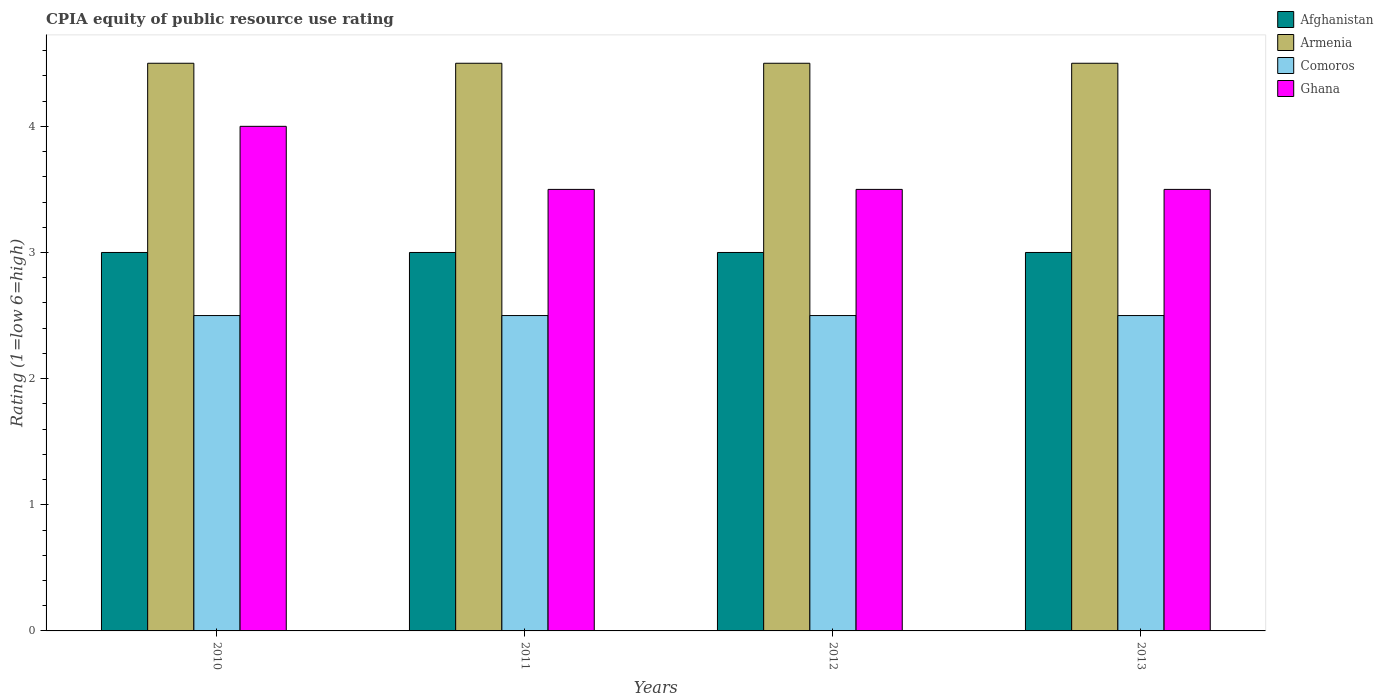What is the label of the 4th group of bars from the left?
Your answer should be very brief. 2013. Across all years, what is the minimum CPIA rating in Ghana?
Offer a terse response. 3.5. In which year was the CPIA rating in Armenia minimum?
Keep it short and to the point. 2010. What is the difference between the CPIA rating in Afghanistan in 2011 and the CPIA rating in Comoros in 2012?
Provide a succinct answer. 0.5. What is the average CPIA rating in Armenia per year?
Make the answer very short. 4.5. In the year 2010, what is the difference between the CPIA rating in Afghanistan and CPIA rating in Armenia?
Ensure brevity in your answer.  -1.5. What is the ratio of the CPIA rating in Armenia in 2010 to that in 2011?
Your answer should be very brief. 1. What is the difference between the highest and the lowest CPIA rating in Afghanistan?
Offer a terse response. 0. Is it the case that in every year, the sum of the CPIA rating in Armenia and CPIA rating in Afghanistan is greater than the sum of CPIA rating in Comoros and CPIA rating in Ghana?
Your response must be concise. No. What does the 3rd bar from the left in 2010 represents?
Make the answer very short. Comoros. What does the 4th bar from the right in 2012 represents?
Your answer should be very brief. Afghanistan. Is it the case that in every year, the sum of the CPIA rating in Ghana and CPIA rating in Armenia is greater than the CPIA rating in Afghanistan?
Your answer should be compact. Yes. How many years are there in the graph?
Offer a very short reply. 4. What is the difference between two consecutive major ticks on the Y-axis?
Your response must be concise. 1. Are the values on the major ticks of Y-axis written in scientific E-notation?
Your answer should be compact. No. Does the graph contain grids?
Offer a very short reply. No. Where does the legend appear in the graph?
Provide a succinct answer. Top right. How many legend labels are there?
Your answer should be very brief. 4. How are the legend labels stacked?
Provide a succinct answer. Vertical. What is the title of the graph?
Offer a terse response. CPIA equity of public resource use rating. What is the label or title of the X-axis?
Ensure brevity in your answer.  Years. What is the label or title of the Y-axis?
Offer a terse response. Rating (1=low 6=high). What is the Rating (1=low 6=high) in Ghana in 2010?
Your response must be concise. 4. What is the Rating (1=low 6=high) in Armenia in 2011?
Offer a terse response. 4.5. What is the Rating (1=low 6=high) in Ghana in 2011?
Provide a short and direct response. 3.5. What is the Rating (1=low 6=high) in Armenia in 2013?
Offer a terse response. 4.5. What is the Rating (1=low 6=high) in Ghana in 2013?
Give a very brief answer. 3.5. Across all years, what is the maximum Rating (1=low 6=high) of Comoros?
Provide a succinct answer. 2.5. Across all years, what is the minimum Rating (1=low 6=high) in Afghanistan?
Keep it short and to the point. 3. Across all years, what is the minimum Rating (1=low 6=high) of Armenia?
Provide a succinct answer. 4.5. Across all years, what is the minimum Rating (1=low 6=high) of Ghana?
Your response must be concise. 3.5. What is the total Rating (1=low 6=high) in Afghanistan in the graph?
Offer a very short reply. 12. What is the total Rating (1=low 6=high) in Armenia in the graph?
Your answer should be very brief. 18. What is the total Rating (1=low 6=high) in Comoros in the graph?
Provide a short and direct response. 10. What is the difference between the Rating (1=low 6=high) of Afghanistan in 2010 and that in 2011?
Provide a succinct answer. 0. What is the difference between the Rating (1=low 6=high) of Armenia in 2010 and that in 2012?
Make the answer very short. 0. What is the difference between the Rating (1=low 6=high) of Comoros in 2010 and that in 2012?
Your answer should be very brief. 0. What is the difference between the Rating (1=low 6=high) in Ghana in 2010 and that in 2012?
Give a very brief answer. 0.5. What is the difference between the Rating (1=low 6=high) in Armenia in 2010 and that in 2013?
Keep it short and to the point. 0. What is the difference between the Rating (1=low 6=high) of Comoros in 2010 and that in 2013?
Ensure brevity in your answer.  0. What is the difference between the Rating (1=low 6=high) in Ghana in 2010 and that in 2013?
Your answer should be very brief. 0.5. What is the difference between the Rating (1=low 6=high) of Comoros in 2011 and that in 2012?
Provide a short and direct response. 0. What is the difference between the Rating (1=low 6=high) of Afghanistan in 2011 and that in 2013?
Ensure brevity in your answer.  0. What is the difference between the Rating (1=low 6=high) of Ghana in 2011 and that in 2013?
Give a very brief answer. 0. What is the difference between the Rating (1=low 6=high) in Ghana in 2012 and that in 2013?
Your response must be concise. 0. What is the difference between the Rating (1=low 6=high) in Afghanistan in 2010 and the Rating (1=low 6=high) in Armenia in 2011?
Ensure brevity in your answer.  -1.5. What is the difference between the Rating (1=low 6=high) in Afghanistan in 2010 and the Rating (1=low 6=high) in Comoros in 2011?
Offer a very short reply. 0.5. What is the difference between the Rating (1=low 6=high) in Afghanistan in 2010 and the Rating (1=low 6=high) in Ghana in 2011?
Offer a terse response. -0.5. What is the difference between the Rating (1=low 6=high) in Armenia in 2010 and the Rating (1=low 6=high) in Ghana in 2011?
Provide a succinct answer. 1. What is the difference between the Rating (1=low 6=high) in Comoros in 2010 and the Rating (1=low 6=high) in Ghana in 2011?
Your answer should be very brief. -1. What is the difference between the Rating (1=low 6=high) of Afghanistan in 2010 and the Rating (1=low 6=high) of Armenia in 2012?
Your response must be concise. -1.5. What is the difference between the Rating (1=low 6=high) of Afghanistan in 2010 and the Rating (1=low 6=high) of Comoros in 2012?
Provide a succinct answer. 0.5. What is the difference between the Rating (1=low 6=high) in Afghanistan in 2010 and the Rating (1=low 6=high) in Comoros in 2013?
Provide a succinct answer. 0.5. What is the difference between the Rating (1=low 6=high) in Armenia in 2010 and the Rating (1=low 6=high) in Ghana in 2013?
Your answer should be very brief. 1. What is the difference between the Rating (1=low 6=high) in Afghanistan in 2011 and the Rating (1=low 6=high) in Ghana in 2013?
Provide a short and direct response. -0.5. What is the difference between the Rating (1=low 6=high) of Armenia in 2011 and the Rating (1=low 6=high) of Ghana in 2013?
Offer a very short reply. 1. What is the difference between the Rating (1=low 6=high) in Afghanistan in 2012 and the Rating (1=low 6=high) in Armenia in 2013?
Ensure brevity in your answer.  -1.5. What is the difference between the Rating (1=low 6=high) in Armenia in 2012 and the Rating (1=low 6=high) in Ghana in 2013?
Ensure brevity in your answer.  1. What is the difference between the Rating (1=low 6=high) in Comoros in 2012 and the Rating (1=low 6=high) in Ghana in 2013?
Offer a very short reply. -1. What is the average Rating (1=low 6=high) of Afghanistan per year?
Provide a succinct answer. 3. What is the average Rating (1=low 6=high) in Armenia per year?
Offer a terse response. 4.5. What is the average Rating (1=low 6=high) of Ghana per year?
Keep it short and to the point. 3.62. In the year 2010, what is the difference between the Rating (1=low 6=high) of Afghanistan and Rating (1=low 6=high) of Comoros?
Keep it short and to the point. 0.5. In the year 2010, what is the difference between the Rating (1=low 6=high) in Afghanistan and Rating (1=low 6=high) in Ghana?
Provide a short and direct response. -1. In the year 2010, what is the difference between the Rating (1=low 6=high) of Armenia and Rating (1=low 6=high) of Comoros?
Your answer should be very brief. 2. In the year 2010, what is the difference between the Rating (1=low 6=high) in Comoros and Rating (1=low 6=high) in Ghana?
Your answer should be compact. -1.5. In the year 2011, what is the difference between the Rating (1=low 6=high) of Afghanistan and Rating (1=low 6=high) of Armenia?
Keep it short and to the point. -1.5. In the year 2011, what is the difference between the Rating (1=low 6=high) of Afghanistan and Rating (1=low 6=high) of Comoros?
Give a very brief answer. 0.5. In the year 2011, what is the difference between the Rating (1=low 6=high) in Afghanistan and Rating (1=low 6=high) in Ghana?
Ensure brevity in your answer.  -0.5. In the year 2011, what is the difference between the Rating (1=low 6=high) of Comoros and Rating (1=low 6=high) of Ghana?
Give a very brief answer. -1. In the year 2012, what is the difference between the Rating (1=low 6=high) of Afghanistan and Rating (1=low 6=high) of Comoros?
Offer a very short reply. 0.5. In the year 2012, what is the difference between the Rating (1=low 6=high) of Armenia and Rating (1=low 6=high) of Comoros?
Your response must be concise. 2. In the year 2013, what is the difference between the Rating (1=low 6=high) of Afghanistan and Rating (1=low 6=high) of Armenia?
Your answer should be compact. -1.5. In the year 2013, what is the difference between the Rating (1=low 6=high) of Afghanistan and Rating (1=low 6=high) of Comoros?
Offer a terse response. 0.5. In the year 2013, what is the difference between the Rating (1=low 6=high) of Afghanistan and Rating (1=low 6=high) of Ghana?
Your answer should be very brief. -0.5. In the year 2013, what is the difference between the Rating (1=low 6=high) in Armenia and Rating (1=low 6=high) in Comoros?
Offer a very short reply. 2. In the year 2013, what is the difference between the Rating (1=low 6=high) in Armenia and Rating (1=low 6=high) in Ghana?
Ensure brevity in your answer.  1. In the year 2013, what is the difference between the Rating (1=low 6=high) of Comoros and Rating (1=low 6=high) of Ghana?
Your response must be concise. -1. What is the ratio of the Rating (1=low 6=high) in Afghanistan in 2010 to that in 2011?
Offer a terse response. 1. What is the ratio of the Rating (1=low 6=high) in Comoros in 2010 to that in 2011?
Provide a succinct answer. 1. What is the ratio of the Rating (1=low 6=high) of Afghanistan in 2010 to that in 2012?
Make the answer very short. 1. What is the ratio of the Rating (1=low 6=high) in Ghana in 2010 to that in 2012?
Give a very brief answer. 1.14. What is the ratio of the Rating (1=low 6=high) in Ghana in 2011 to that in 2012?
Provide a succinct answer. 1. What is the ratio of the Rating (1=low 6=high) of Armenia in 2011 to that in 2013?
Your answer should be compact. 1. What is the ratio of the Rating (1=low 6=high) in Comoros in 2011 to that in 2013?
Provide a succinct answer. 1. What is the ratio of the Rating (1=low 6=high) in Afghanistan in 2012 to that in 2013?
Make the answer very short. 1. What is the difference between the highest and the second highest Rating (1=low 6=high) in Afghanistan?
Provide a succinct answer. 0. What is the difference between the highest and the second highest Rating (1=low 6=high) of Armenia?
Keep it short and to the point. 0. What is the difference between the highest and the second highest Rating (1=low 6=high) in Ghana?
Offer a very short reply. 0.5. What is the difference between the highest and the lowest Rating (1=low 6=high) of Comoros?
Give a very brief answer. 0. 